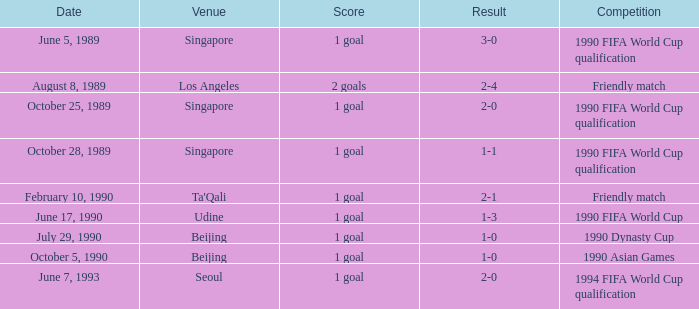What is the competition at the ta'qali venue? Friendly match. 